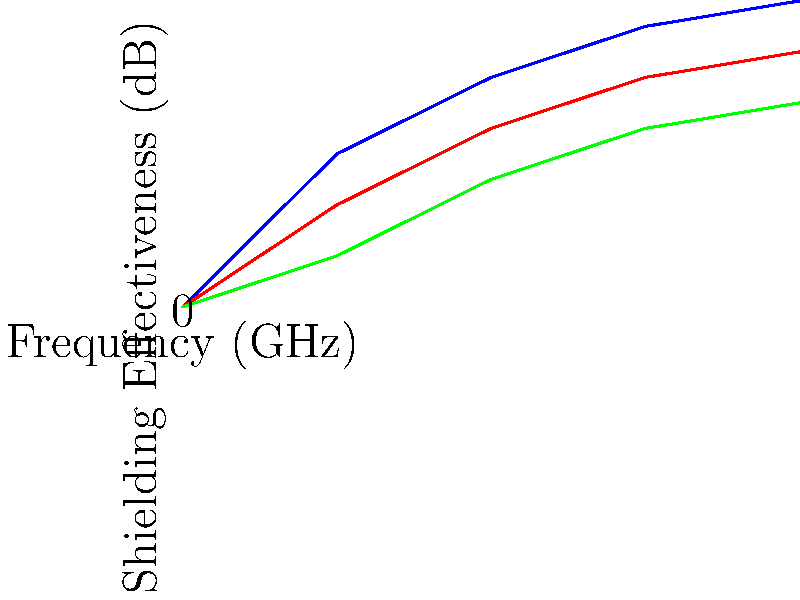As a military engineer working on communication devices for the Singapore Armed Forces, you are tasked with selecting the most effective material for electromagnetic shielding. The graph shows the shielding effectiveness of three different materials (A, B, and C) across various frequencies. Based on the data presented, which material would you recommend for a device operating at 3 GHz, and what is its approximate shielding effectiveness at this frequency? To answer this question, we need to follow these steps:

1. Identify the operating frequency: 3 GHz

2. Examine the graph for each material's performance at 3 GHz:
   - Material A (blue line): Approximately 55 dB
   - Material B (red line): Approximately 45 dB
   - Material C (green line): Approximately 35 dB

3. Compare the shielding effectiveness values:
   Material A > Material B > Material C

4. Select the material with the highest shielding effectiveness:
   Material A has the highest shielding effectiveness at 3 GHz.

5. Determine the approximate shielding effectiveness:
   At 3 GHz, Material A provides approximately 55 dB of shielding.

Therefore, as a military engineer focused on maximizing electromagnetic shielding for communication devices, you would recommend Material A for a device operating at 3 GHz. The shielding effectiveness of Material A at this frequency is approximately 55 dB.
Answer: Material A, 55 dB 